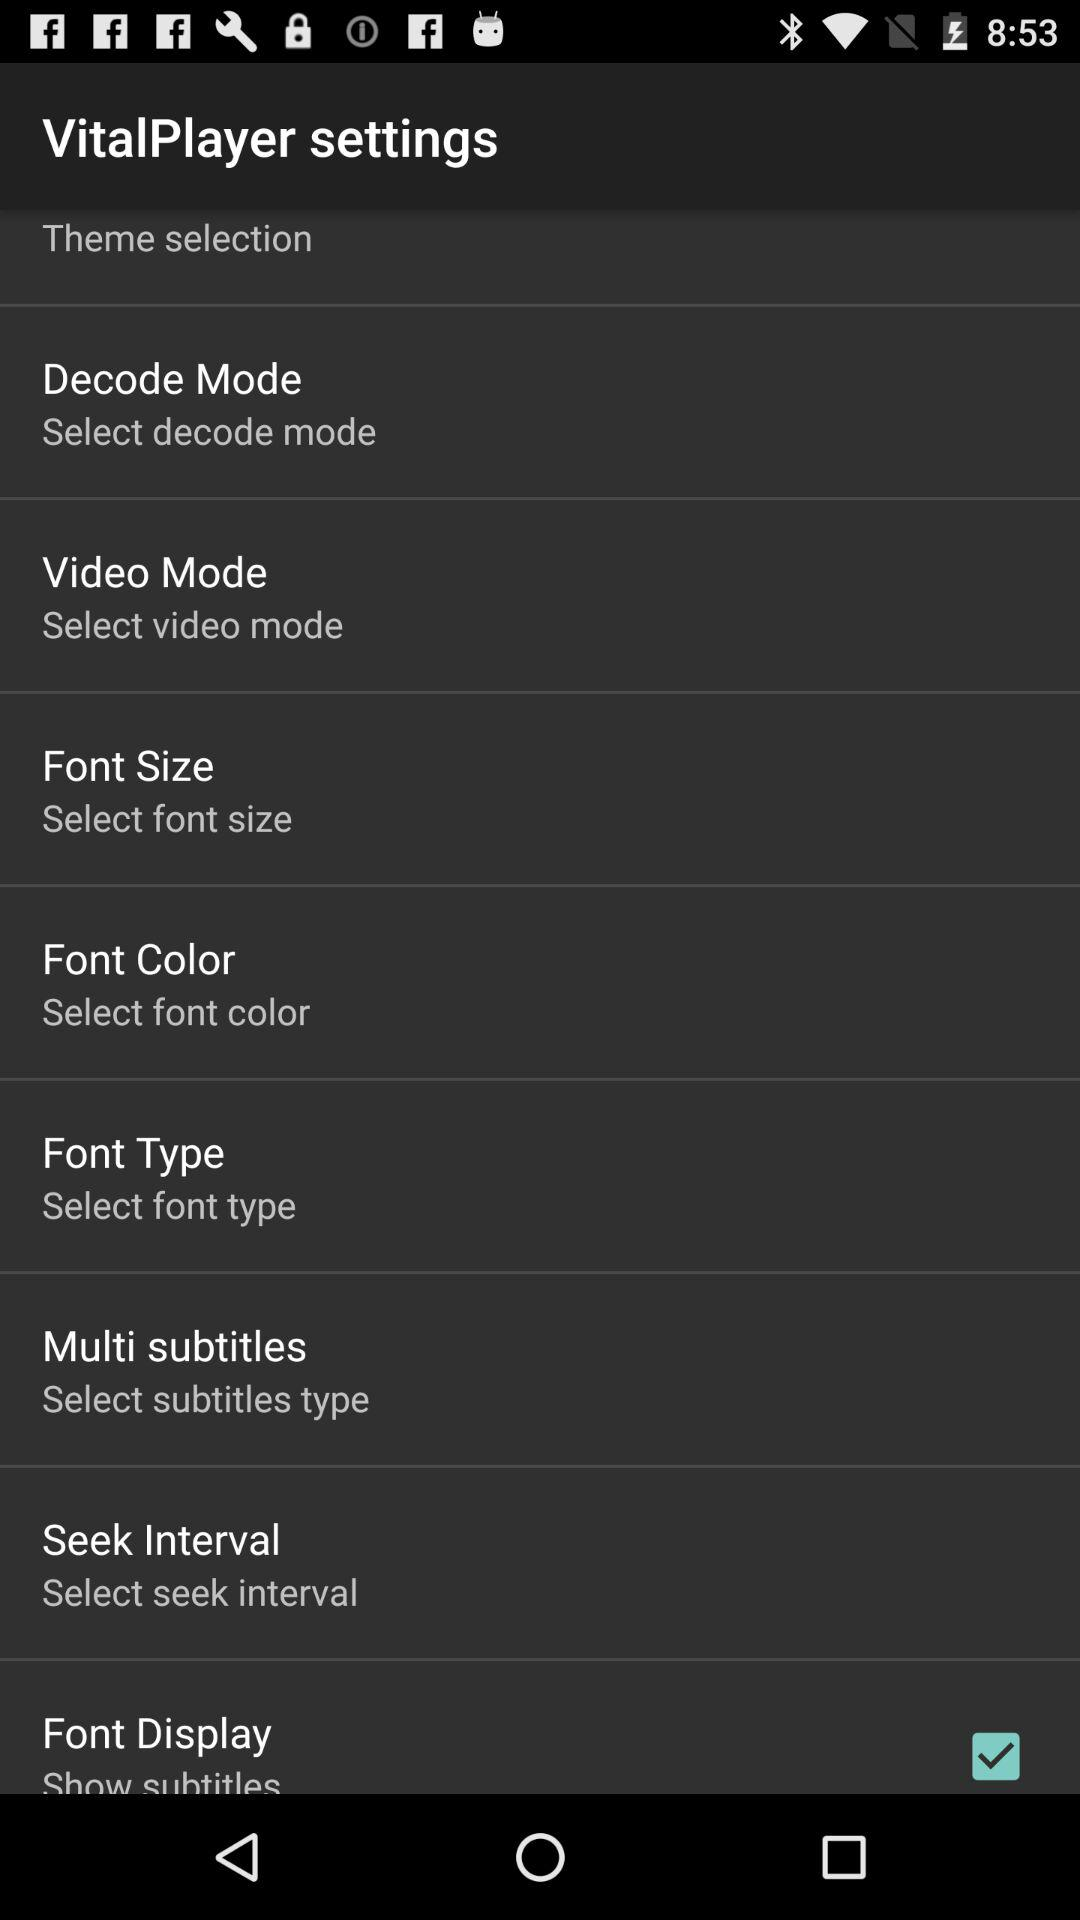What customization options does VitalPlayer offer? VitalPlayer offers several customization options including theme selection, decode mode, video mode, font size, font color, font type, multi subtitles, seek interval, and font display options. These features enhance the user's viewing experience by allowing for significant personalization of the app's functionality and appearance. 